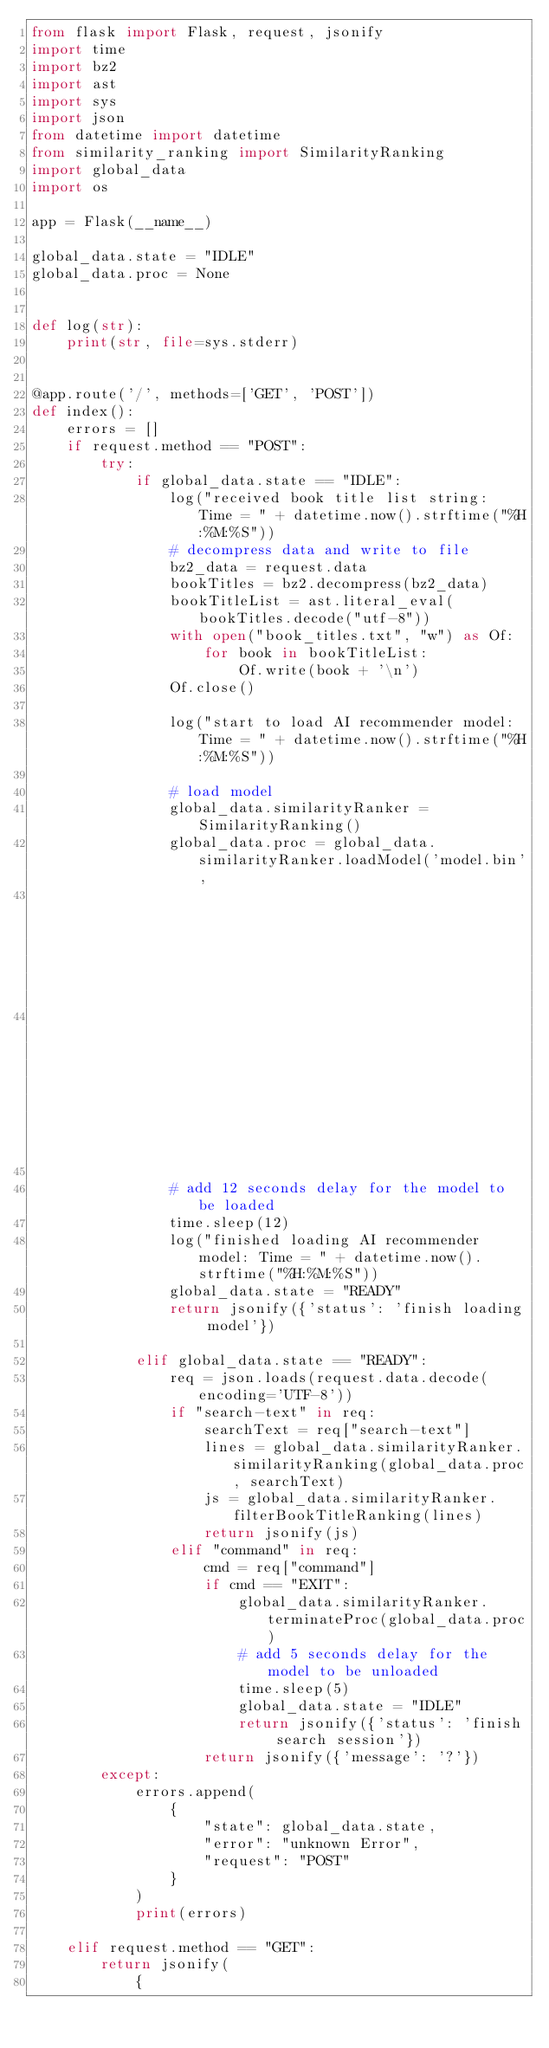Convert code to text. <code><loc_0><loc_0><loc_500><loc_500><_Python_>from flask import Flask, request, jsonify
import time
import bz2
import ast
import sys
import json
from datetime import datetime
from similarity_ranking import SimilarityRanking
import global_data
import os

app = Flask(__name__)

global_data.state = "IDLE"
global_data.proc = None


def log(str):
    print(str, file=sys.stderr)


@app.route('/', methods=['GET', 'POST'])
def index():
    errors = []
    if request.method == "POST":
        try:
            if global_data.state == "IDLE":
                log("received book title list string: Time = " + datetime.now().strftime("%H:%M:%S"))
                # decompress data and write to file
                bz2_data = request.data
                bookTitles = bz2.decompress(bz2_data)
                bookTitleList = ast.literal_eval(bookTitles.decode("utf-8"))
                with open("book_titles.txt", "w") as Of:
                    for book in bookTitleList:
                        Of.write(book + '\n')
                Of.close()

                log("start to load AI recommender model: Time = " + datetime.now().strftime("%H:%M:%S"))

                # load model
                global_data.similarityRanker = SimilarityRanking()
                global_data.proc = global_data.similarityRanker.loadModel('model.bin',
                                                                          'book_titles.txt',
                                                                          os.environ['N_BEST'])

                # add 12 seconds delay for the model to be loaded
                time.sleep(12)
                log("finished loading AI recommender model: Time = " + datetime.now().strftime("%H:%M:%S"))
                global_data.state = "READY"
                return jsonify({'status': 'finish loading model'})

            elif global_data.state == "READY":
                req = json.loads(request.data.decode(encoding='UTF-8'))
                if "search-text" in req:
                    searchText = req["search-text"]
                    lines = global_data.similarityRanker.similarityRanking(global_data.proc, searchText)
                    js = global_data.similarityRanker.filterBookTitleRanking(lines)
                    return jsonify(js)
                elif "command" in req:
                    cmd = req["command"]
                    if cmd == "EXIT":
                        global_data.similarityRanker.terminateProc(global_data.proc)
                        # add 5 seconds delay for the model to be unloaded
                        time.sleep(5)
                        global_data.state = "IDLE"
                        return jsonify({'status': 'finish search session'})
                    return jsonify({'message': '?'})
        except:
            errors.append(
                {
                    "state": global_data.state,
                    "error": "unknown Error",
                    "request": "POST"
                }
            )
            print(errors)

    elif request.method == "GET":
        return jsonify(
            {</code> 